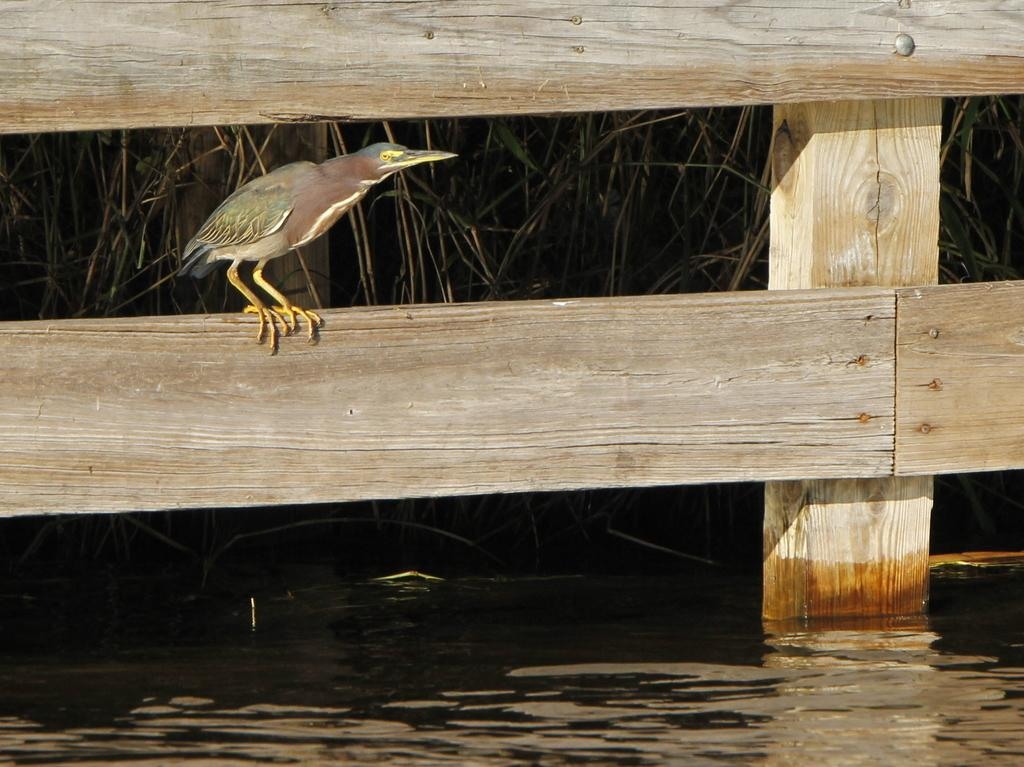What type of animal is in the image? There is a bird in the image. Where is the bird located? The bird is standing on a wooden railing. What can be seen behind the railing? There are plants behind the railing. What is visible at the bottom of the image? There is water visible at the bottom of the image. Can you hear the bird coughing in the image? There is no sound in the image, so it is not possible to hear the bird coughing. 